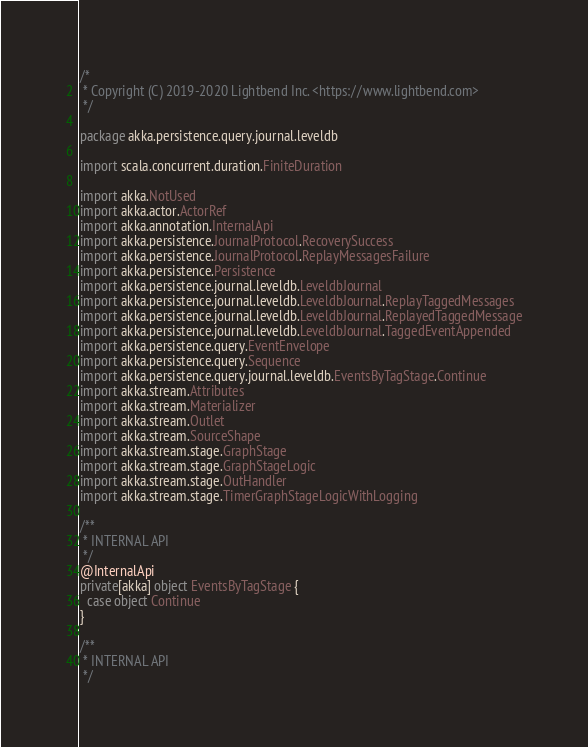<code> <loc_0><loc_0><loc_500><loc_500><_Scala_>/*
 * Copyright (C) 2019-2020 Lightbend Inc. <https://www.lightbend.com>
 */

package akka.persistence.query.journal.leveldb

import scala.concurrent.duration.FiniteDuration

import akka.NotUsed
import akka.actor.ActorRef
import akka.annotation.InternalApi
import akka.persistence.JournalProtocol.RecoverySuccess
import akka.persistence.JournalProtocol.ReplayMessagesFailure
import akka.persistence.Persistence
import akka.persistence.journal.leveldb.LeveldbJournal
import akka.persistence.journal.leveldb.LeveldbJournal.ReplayTaggedMessages
import akka.persistence.journal.leveldb.LeveldbJournal.ReplayedTaggedMessage
import akka.persistence.journal.leveldb.LeveldbJournal.TaggedEventAppended
import akka.persistence.query.EventEnvelope
import akka.persistence.query.Sequence
import akka.persistence.query.journal.leveldb.EventsByTagStage.Continue
import akka.stream.Attributes
import akka.stream.Materializer
import akka.stream.Outlet
import akka.stream.SourceShape
import akka.stream.stage.GraphStage
import akka.stream.stage.GraphStageLogic
import akka.stream.stage.OutHandler
import akka.stream.stage.TimerGraphStageLogicWithLogging

/**
 * INTERNAL API
 */
@InternalApi
private[akka] object EventsByTagStage {
  case object Continue
}

/**
 * INTERNAL API
 */</code> 